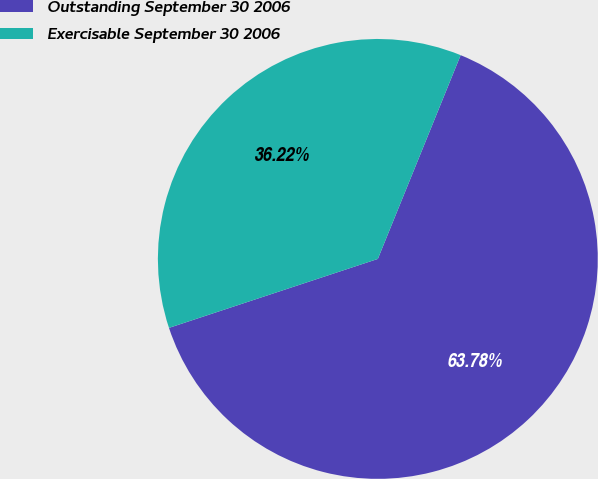Convert chart to OTSL. <chart><loc_0><loc_0><loc_500><loc_500><pie_chart><fcel>Outstanding September 30 2006<fcel>Exercisable September 30 2006<nl><fcel>63.78%<fcel>36.22%<nl></chart> 